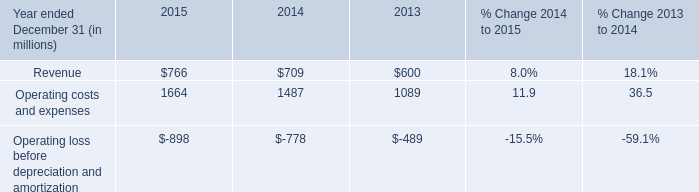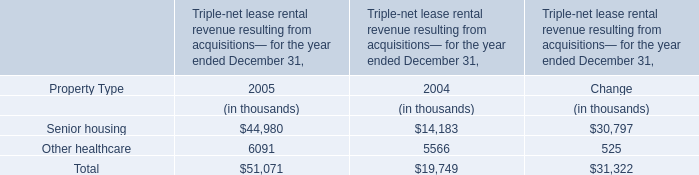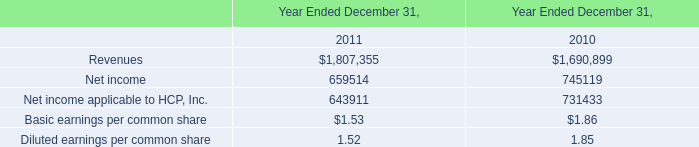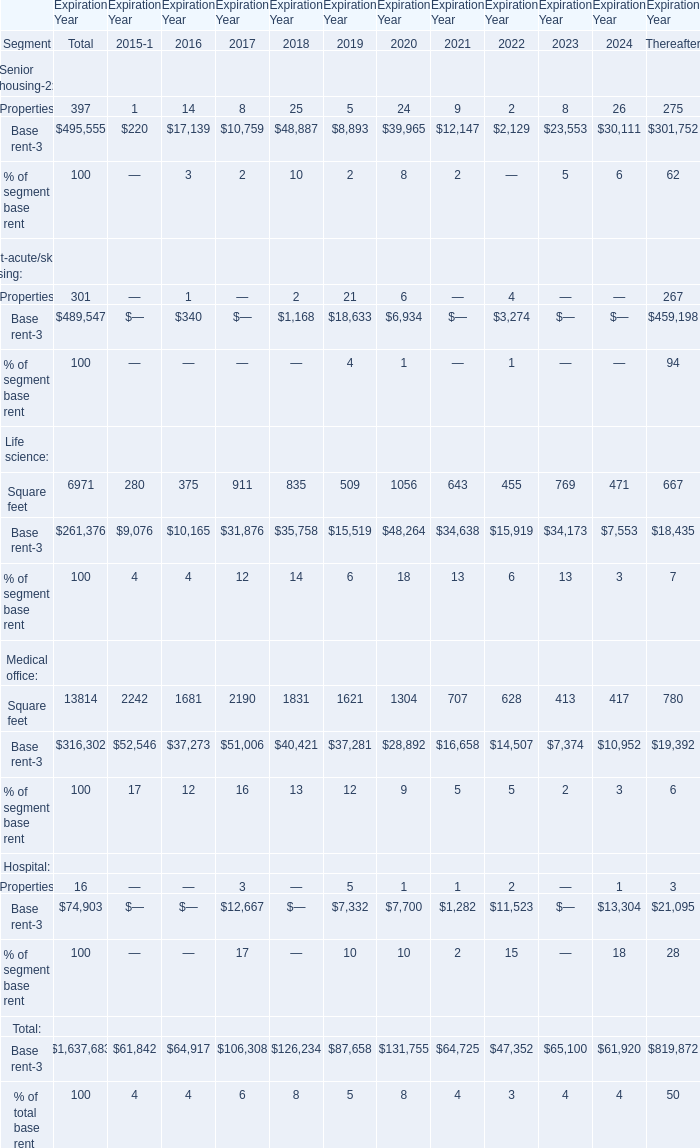Is the total amount of all elements in2016 greater than that in2017? 
Answer: no. 